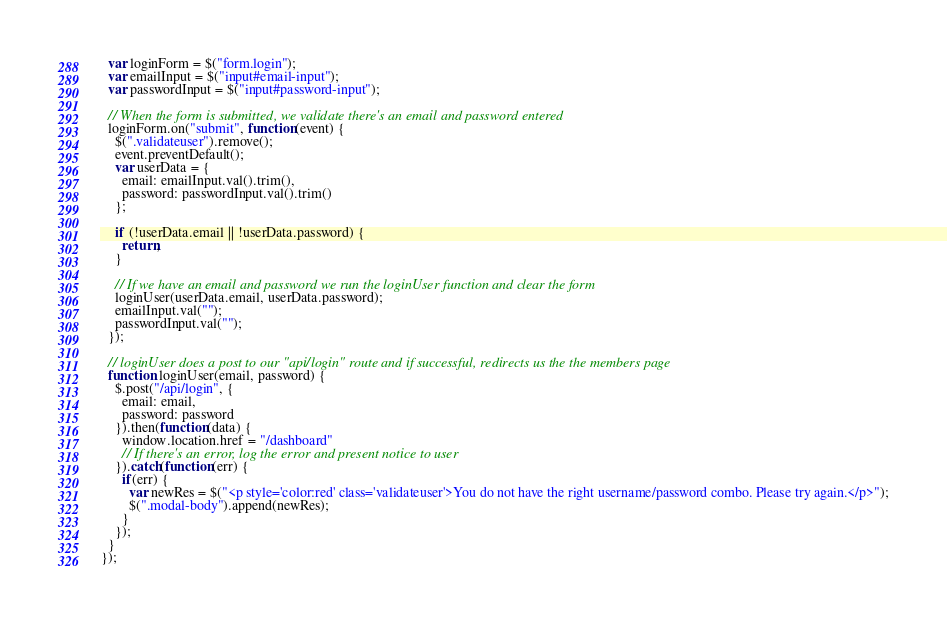<code> <loc_0><loc_0><loc_500><loc_500><_JavaScript_>  var loginForm = $("form.login");
  var emailInput = $("input#email-input");
  var passwordInput = $("input#password-input");

  // When the form is submitted, we validate there's an email and password entered
  loginForm.on("submit", function(event) {
    $(".validateuser").remove();
    event.preventDefault();
    var userData = {
      email: emailInput.val().trim(),
      password: passwordInput.val().trim()
    };

    if (!userData.email || !userData.password) {
      return;
    }

    // If we have an email and password we run the loginUser function and clear the form
    loginUser(userData.email, userData.password);
    emailInput.val("");
    passwordInput.val("");
  });

  // loginUser does a post to our "api/login" route and if successful, redirects us the the members page
  function loginUser(email, password) {
    $.post("/api/login", {
      email: email,
      password: password
    }).then(function(data) {
      window.location.href = "/dashboard"
      // If there's an error, log the error and present notice to user
    }).catch(function(err) {
      if(err) {
        var newRes = $("<p style='color:red' class='validateuser'>You do not have the right username/password combo. Please try again.</p>");
        $(".modal-body").append(newRes);
      }
    });
  }
});
</code> 